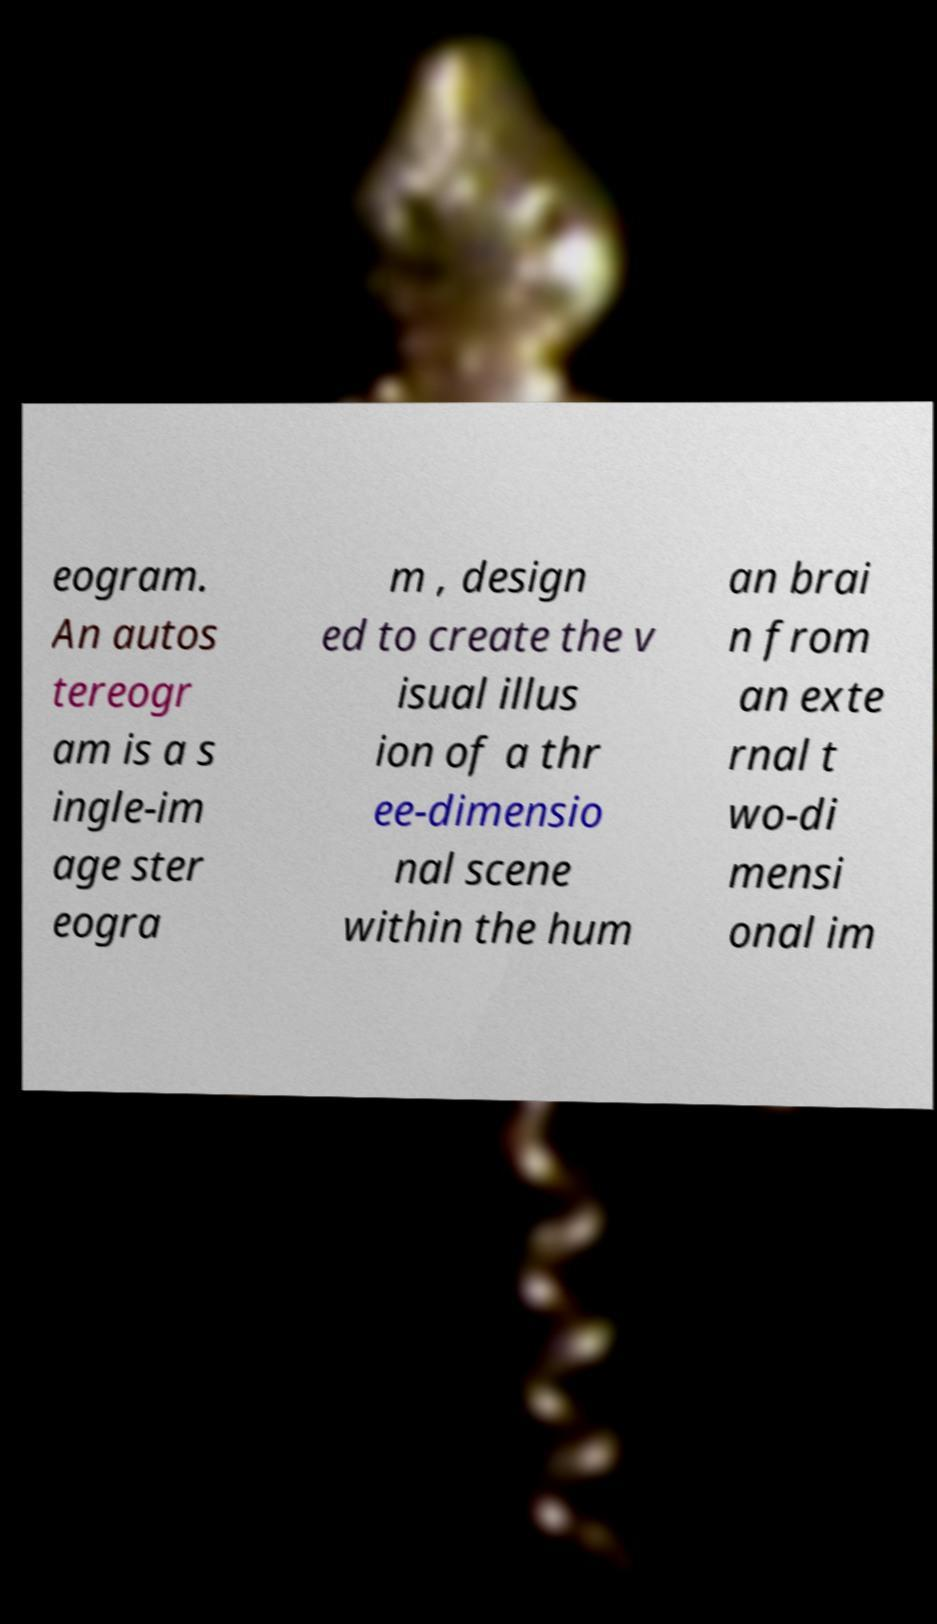For documentation purposes, I need the text within this image transcribed. Could you provide that? eogram. An autos tereogr am is a s ingle-im age ster eogra m , design ed to create the v isual illus ion of a thr ee-dimensio nal scene within the hum an brai n from an exte rnal t wo-di mensi onal im 